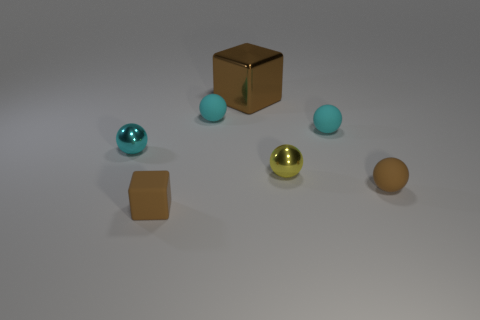Subtract all cyan spheres. How many were subtracted if there are1cyan spheres left? 2 Subtract all cyan cubes. How many cyan balls are left? 3 Subtract all purple balls. Subtract all yellow cubes. How many balls are left? 5 Add 3 tiny metallic spheres. How many objects exist? 10 Subtract all balls. How many objects are left? 2 Subtract all matte objects. Subtract all metal balls. How many objects are left? 1 Add 1 cyan matte objects. How many cyan matte objects are left? 3 Add 1 tiny cyan balls. How many tiny cyan balls exist? 4 Subtract 0 yellow blocks. How many objects are left? 7 